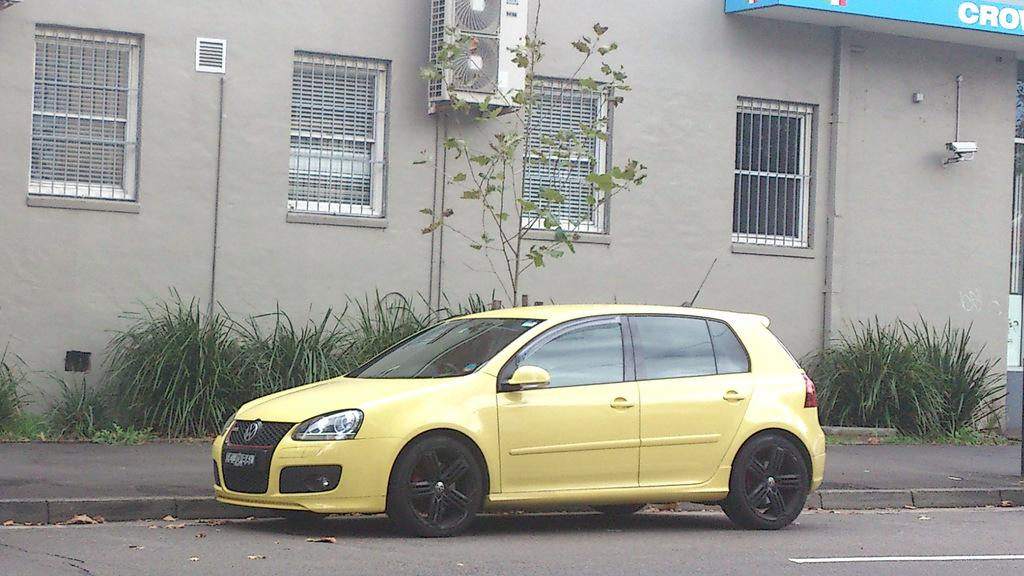What is the main subject in the center of the image? There is a car in the center of the image. Where is the car located? The car is on the road. What can be seen in the background of the image? There is grass, a tree, and a building visible in the background of the image. How many times has the car been folded in the image? The car cannot be folded, so it has not been folded any times in the image. 